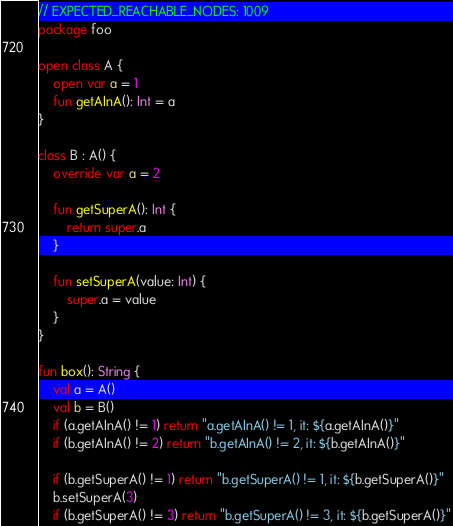<code> <loc_0><loc_0><loc_500><loc_500><_Kotlin_>// EXPECTED_REACHABLE_NODES: 1009
package foo

open class A {
    open var a = 1
    fun getAInA(): Int = a
}

class B : A() {
    override var a = 2

    fun getSuperA(): Int {
        return super.a
    }

    fun setSuperA(value: Int) {
        super.a = value
    }
}

fun box(): String {
    val a = A()
    val b = B()
    if (a.getAInA() != 1) return "a.getAInA() != 1, it: ${a.getAInA()}"
    if (b.getAInA() != 2) return "b.getAInA() != 2, it: ${b.getAInA()}"

    if (b.getSuperA() != 1) return "b.getSuperA() != 1, it: ${b.getSuperA()}"
    b.setSuperA(3)
    if (b.getSuperA() != 3) return "b.getSuperA() != 3, it: ${b.getSuperA()}"
</code> 